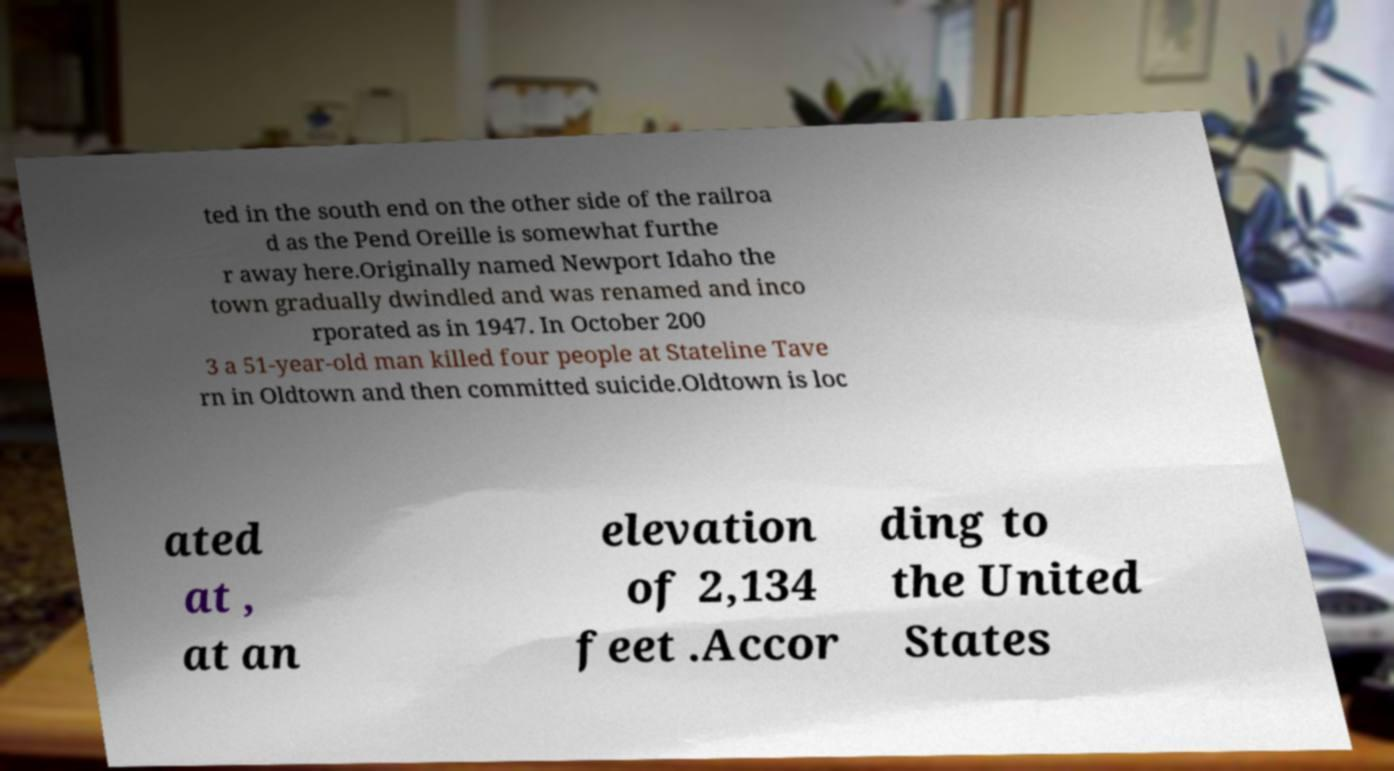Can you accurately transcribe the text from the provided image for me? ted in the south end on the other side of the railroa d as the Pend Oreille is somewhat furthe r away here.Originally named Newport Idaho the town gradually dwindled and was renamed and inco rporated as in 1947. In October 200 3 a 51-year-old man killed four people at Stateline Tave rn in Oldtown and then committed suicide.Oldtown is loc ated at , at an elevation of 2,134 feet .Accor ding to the United States 